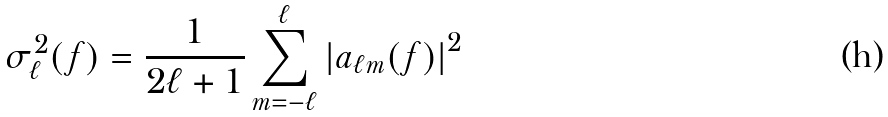<formula> <loc_0><loc_0><loc_500><loc_500>\sigma ^ { 2 } _ { \ell } ( f ) = \frac { 1 } { 2 \ell + 1 } \sum _ { m = - \ell } ^ { \ell } \left | a _ { \ell m } ( f ) \right | ^ { 2 }</formula> 